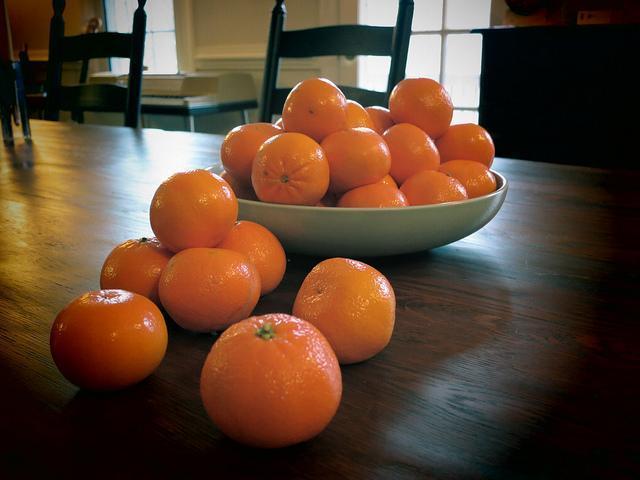How many chairs do you see?
Give a very brief answer. 2. How many oranges are there?
Give a very brief answer. 4. How many chairs are there?
Give a very brief answer. 2. 